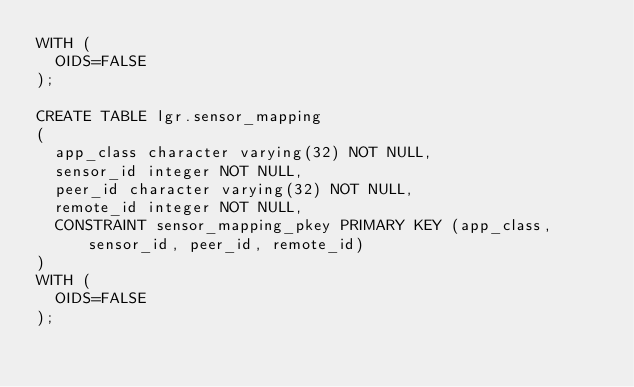<code> <loc_0><loc_0><loc_500><loc_500><_SQL_>WITH (
  OIDS=FALSE
);

CREATE TABLE lgr.sensor_mapping
(
  app_class character varying(32) NOT NULL,
  sensor_id integer NOT NULL,
  peer_id character varying(32) NOT NULL,
  remote_id integer NOT NULL,
  CONSTRAINT sensor_mapping_pkey PRIMARY KEY (app_class, sensor_id, peer_id, remote_id)
)
WITH (
  OIDS=FALSE
);



</code> 